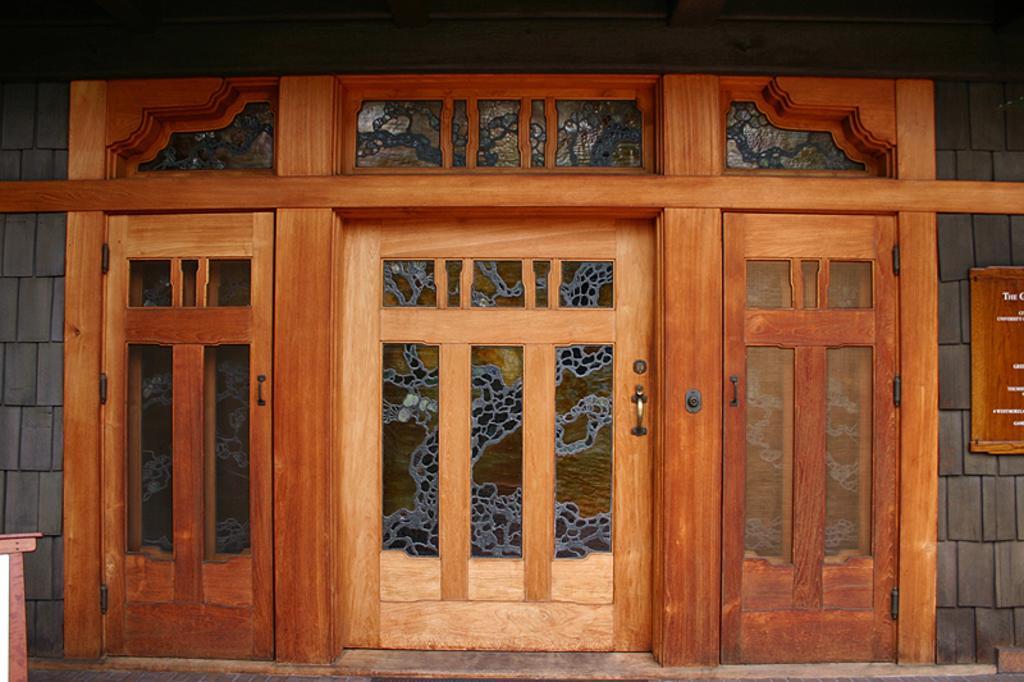In one or two sentences, can you explain what this image depicts? In this image I can see the doors to the wall. To the right I can see the wooden board and something is written on it. 